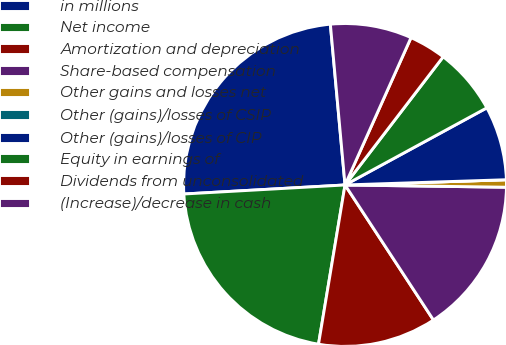Convert chart to OTSL. <chart><loc_0><loc_0><loc_500><loc_500><pie_chart><fcel>in millions<fcel>Net income<fcel>Amortization and depreciation<fcel>Share-based compensation<fcel>Other gains and losses net<fcel>Other (gains)/losses of CSIP<fcel>Other (gains)/losses of CIP<fcel>Equity in earnings of<fcel>Dividends from unconsolidated<fcel>(Increase)/decrease in cash<nl><fcel>24.44%<fcel>21.48%<fcel>11.85%<fcel>15.55%<fcel>0.74%<fcel>0.0%<fcel>7.41%<fcel>6.67%<fcel>3.7%<fcel>8.15%<nl></chart> 